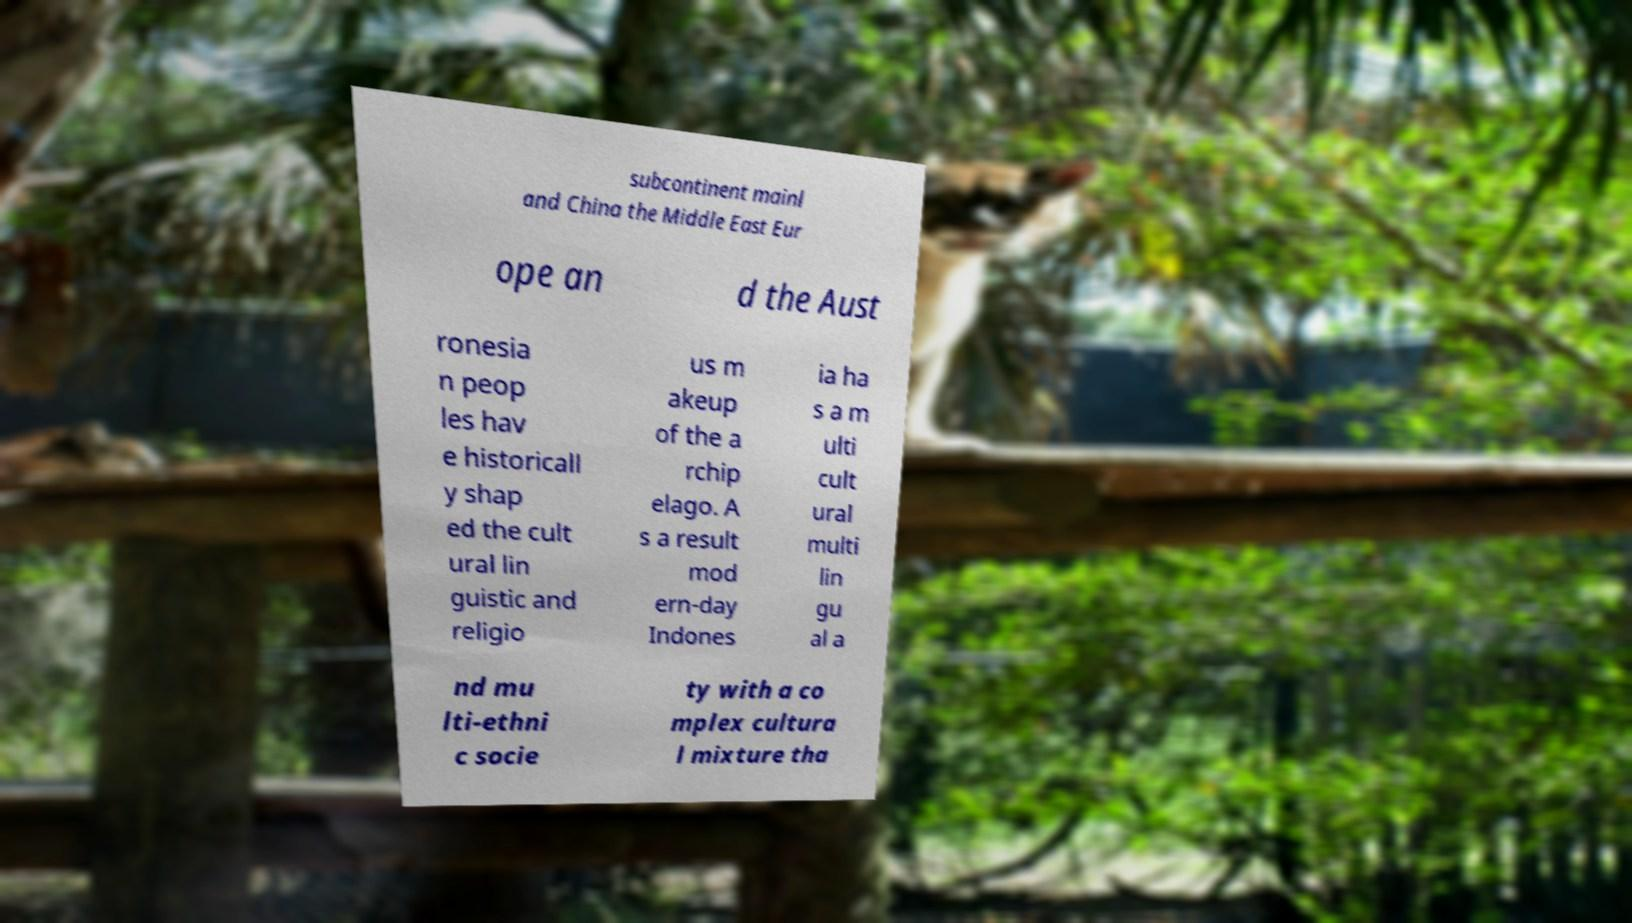Please identify and transcribe the text found in this image. subcontinent mainl and China the Middle East Eur ope an d the Aust ronesia n peop les hav e historicall y shap ed the cult ural lin guistic and religio us m akeup of the a rchip elago. A s a result mod ern-day Indones ia ha s a m ulti cult ural multi lin gu al a nd mu lti-ethni c socie ty with a co mplex cultura l mixture tha 